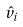Convert formula to latex. <formula><loc_0><loc_0><loc_500><loc_500>\hat { v } _ { i }</formula> 